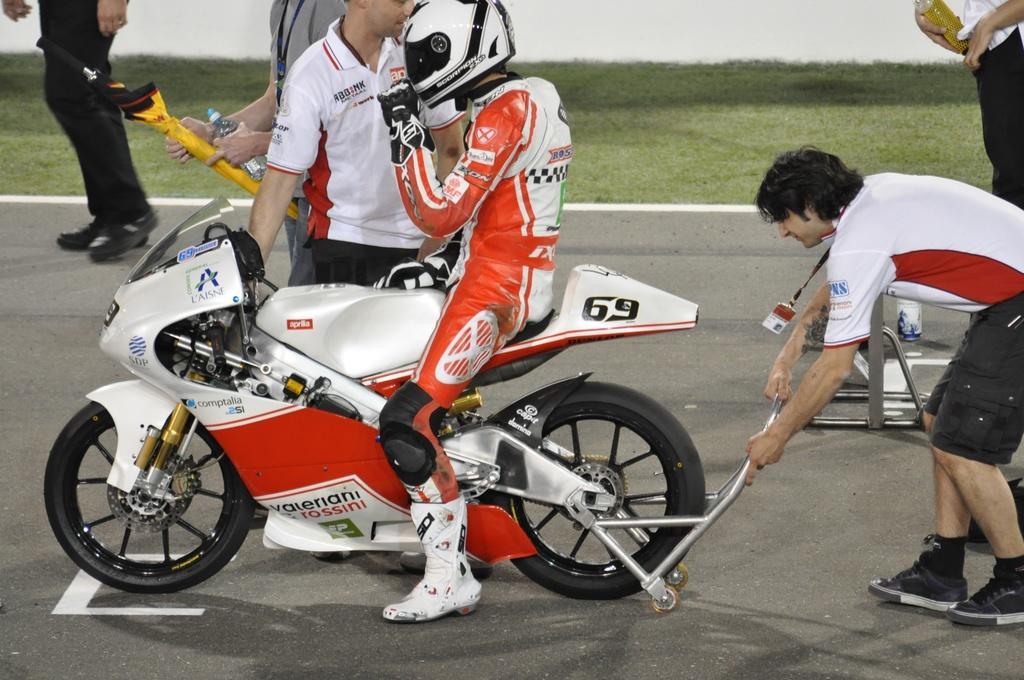Could you give a brief overview of what you see in this image? In this image we can see a motorbike upon which a man wearing orange and white dress is riding it. In the background of the image we can see few people standing on the road. 